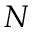Convert formula to latex. <formula><loc_0><loc_0><loc_500><loc_500>N</formula> 